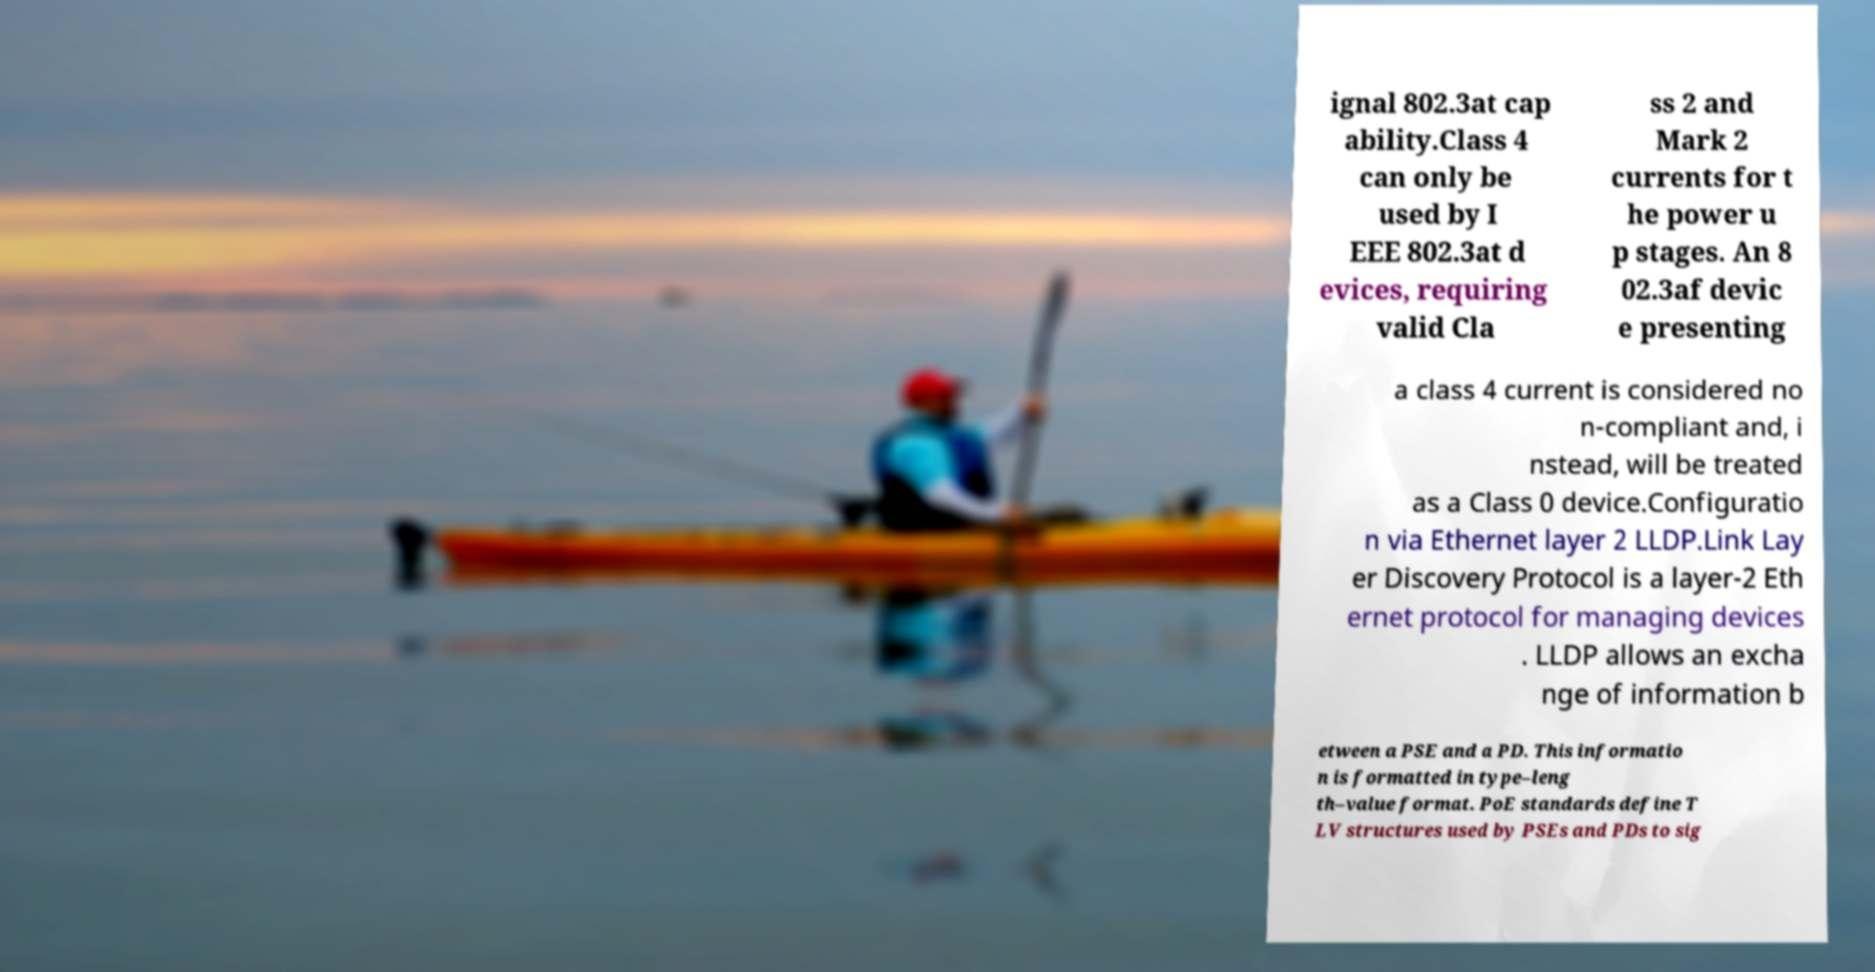What messages or text are displayed in this image? I need them in a readable, typed format. ignal 802.3at cap ability.Class 4 can only be used by I EEE 802.3at d evices, requiring valid Cla ss 2 and Mark 2 currents for t he power u p stages. An 8 02.3af devic e presenting a class 4 current is considered no n-compliant and, i nstead, will be treated as a Class 0 device.Configuratio n via Ethernet layer 2 LLDP.Link Lay er Discovery Protocol is a layer-2 Eth ernet protocol for managing devices . LLDP allows an excha nge of information b etween a PSE and a PD. This informatio n is formatted in type–leng th–value format. PoE standards define T LV structures used by PSEs and PDs to sig 